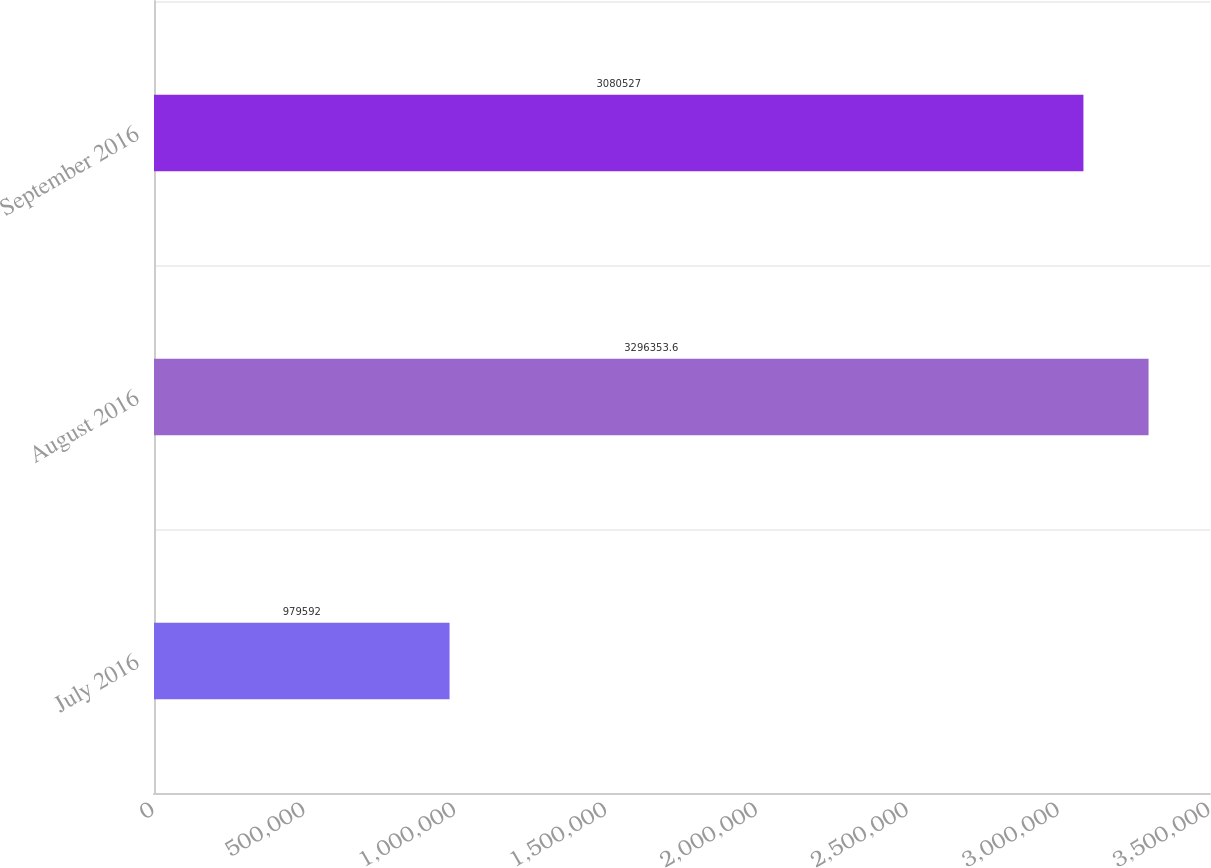Convert chart to OTSL. <chart><loc_0><loc_0><loc_500><loc_500><bar_chart><fcel>July 2016<fcel>August 2016<fcel>September 2016<nl><fcel>979592<fcel>3.29635e+06<fcel>3.08053e+06<nl></chart> 